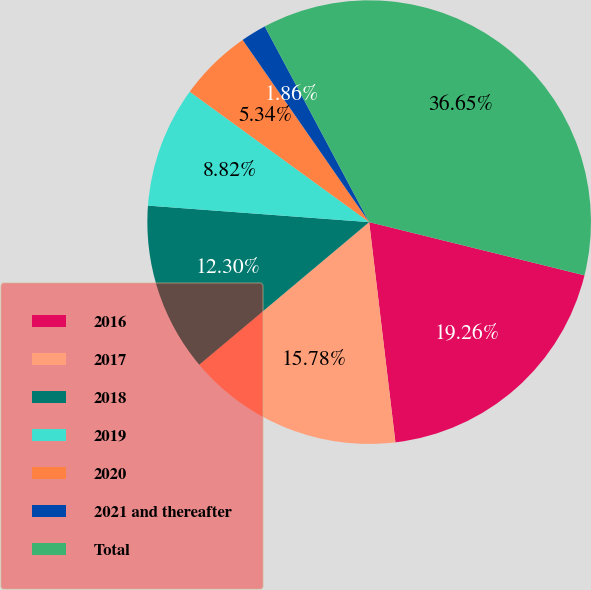<chart> <loc_0><loc_0><loc_500><loc_500><pie_chart><fcel>2016<fcel>2017<fcel>2018<fcel>2019<fcel>2020<fcel>2021 and thereafter<fcel>Total<nl><fcel>19.26%<fcel>15.78%<fcel>12.3%<fcel>8.82%<fcel>5.34%<fcel>1.86%<fcel>36.66%<nl></chart> 